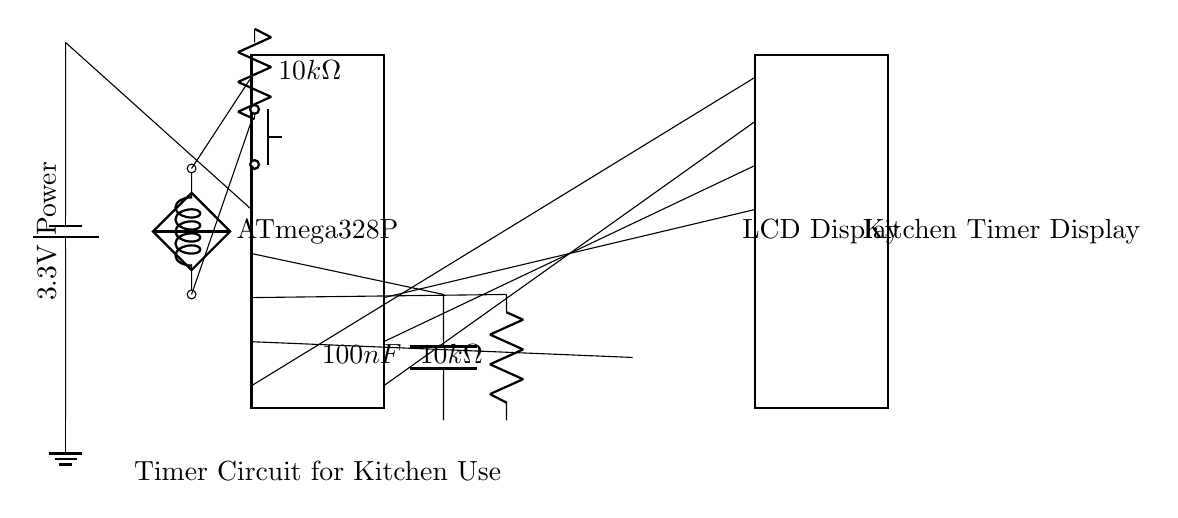What microcontroller is used in this circuit? The circuit diagram shows an ATmega328P microcontroller, which can be identified by the rectangular dip chip symbol at the top left.
Answer: ATmega328P What type of display is included in this circuit? The circuit features a standard LCD display, indicated by the dip chip symbol on the right side of the microcontroller.
Answer: LCD Display What is the value of the capacitor in the timing section? The timing components include a capacitor marked as 100 nanofarads, which can be seen in the lower part of the circuit diagram.
Answer: 100 nanofarads What is the resistance value of the resistor connected to the reset circuit? The reset circuit contains a resistor labeled as 10 kilo-ohms, which is identified near the push button in the diagram.
Answer: 10 kilo-ohms How does the microcontroller connect to the LCD display? The microcontroller connects to the LCD via four pins, which are labeled as pins one through four on the microcontroller side and connect directly to the corresponding LCD pins.
Answer: Four pins What role does the crystal oscillator play in this circuit? The crystal oscillator provides stability in the timing for the microcontroller by generating a consistent frequency, which can be seen along with its connections to the microcontroller.
Answer: Stability in timing What function does the buzzer serve in this timer circuit? The buzzer is connected to the microcontroller and is used to alert when the timer reaches zero or when a reminder is needed, making it critical for the functional aspect of the timer.
Answer: Alert 